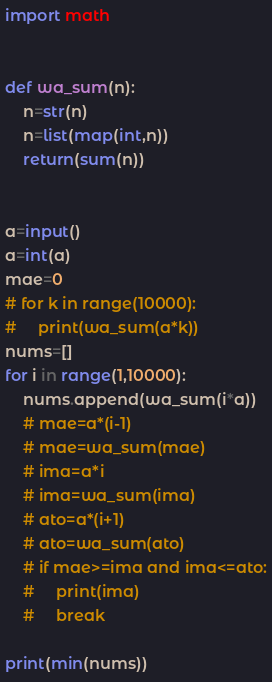<code> <loc_0><loc_0><loc_500><loc_500><_Python_>import math


def wa_sum(n):
    n=str(n)
    n=list(map(int,n))
    return(sum(n))


a=input()
a=int(a)
mae=0
# for k in range(10000):
#     print(wa_sum(a*k))
nums=[]    
for i in range(1,10000):
    nums.append(wa_sum(i*a))
    # mae=a*(i-1)
    # mae=wa_sum(mae)
    # ima=a*i
    # ima=wa_sum(ima)
    # ato=a*(i+1)
    # ato=wa_sum(ato)
    # if mae>=ima and ima<=ato:
    #     print(ima)
    #     break
    
print(min(nums))</code> 